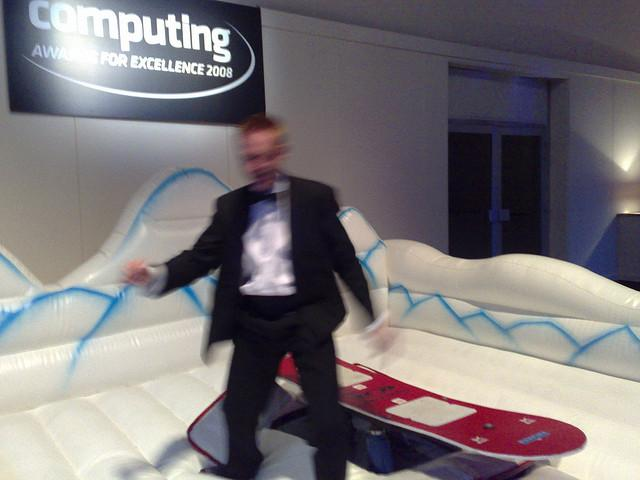The inflatable display is meant to simulate which winter sport? Please explain your reasoning. snowboarding. This is the only one of these sports done with a board on a slope. 